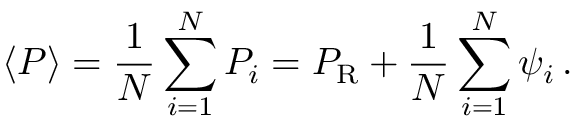Convert formula to latex. <formula><loc_0><loc_0><loc_500><loc_500>\langle P \rangle = { \frac { 1 } { N } } \sum _ { i = 1 } ^ { N } P _ { i } = P _ { \mathrm R } + { \frac { 1 } { N } } \sum _ { i = 1 } ^ { N } \psi _ { i } \, .</formula> 